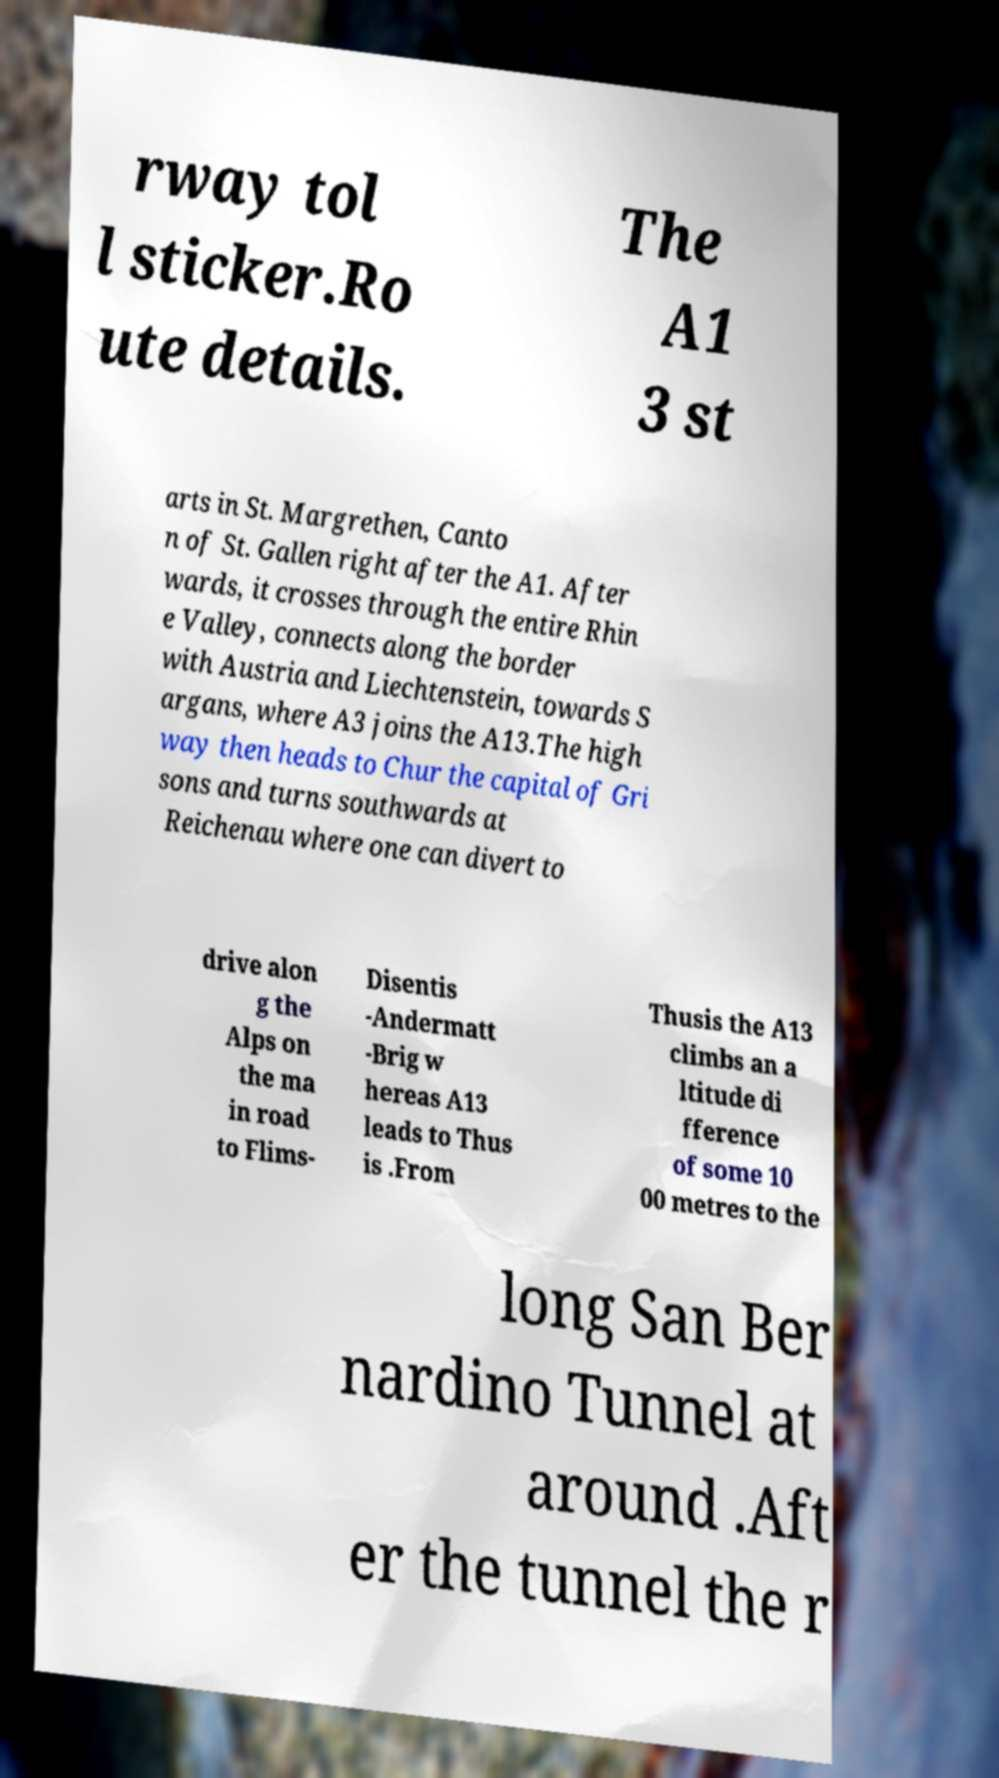There's text embedded in this image that I need extracted. Can you transcribe it verbatim? rway tol l sticker.Ro ute details. The A1 3 st arts in St. Margrethen, Canto n of St. Gallen right after the A1. After wards, it crosses through the entire Rhin e Valley, connects along the border with Austria and Liechtenstein, towards S argans, where A3 joins the A13.The high way then heads to Chur the capital of Gri sons and turns southwards at Reichenau where one can divert to drive alon g the Alps on the ma in road to Flims- Disentis -Andermatt -Brig w hereas A13 leads to Thus is .From Thusis the A13 climbs an a ltitude di fference of some 10 00 metres to the long San Ber nardino Tunnel at around .Aft er the tunnel the r 